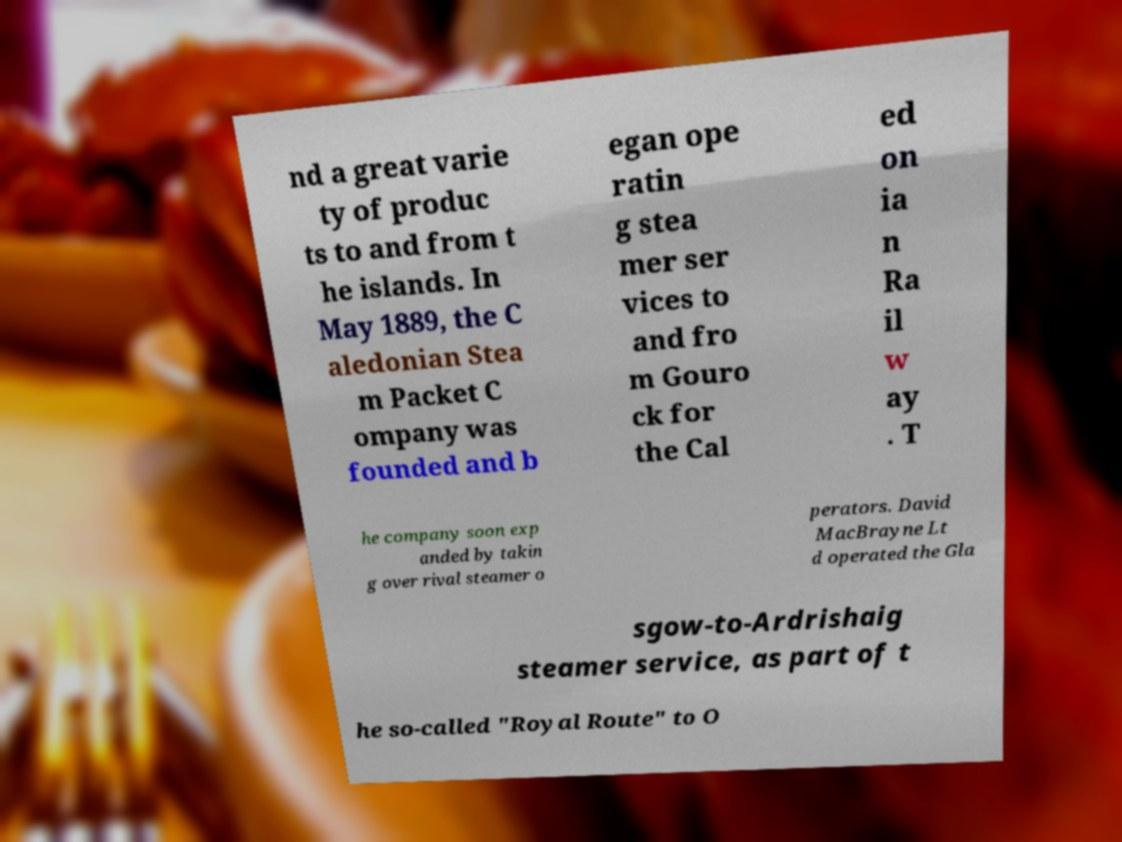For documentation purposes, I need the text within this image transcribed. Could you provide that? nd a great varie ty of produc ts to and from t he islands. In May 1889, the C aledonian Stea m Packet C ompany was founded and b egan ope ratin g stea mer ser vices to and fro m Gouro ck for the Cal ed on ia n Ra il w ay . T he company soon exp anded by takin g over rival steamer o perators. David MacBrayne Lt d operated the Gla sgow-to-Ardrishaig steamer service, as part of t he so-called "Royal Route" to O 